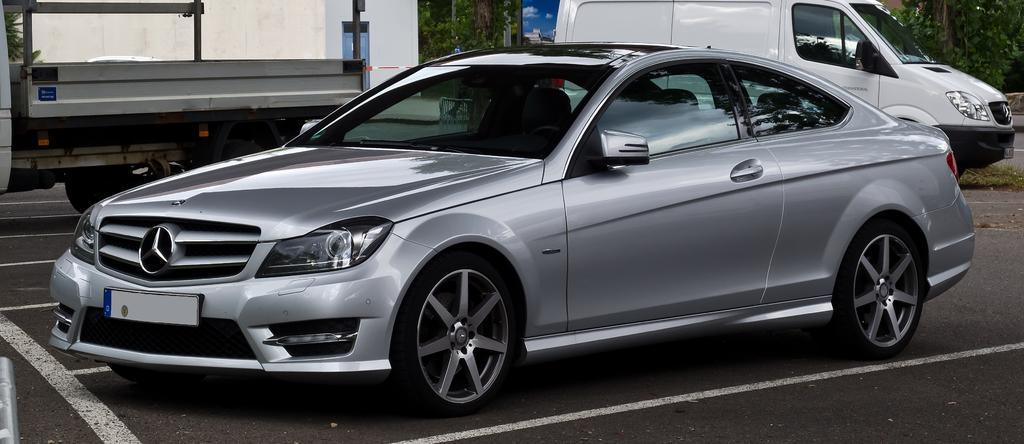Please provide a concise description of this image. In this picture we can see a car in the front, on the right side there is a van, we can see trees in the background, we can see a wall here. 